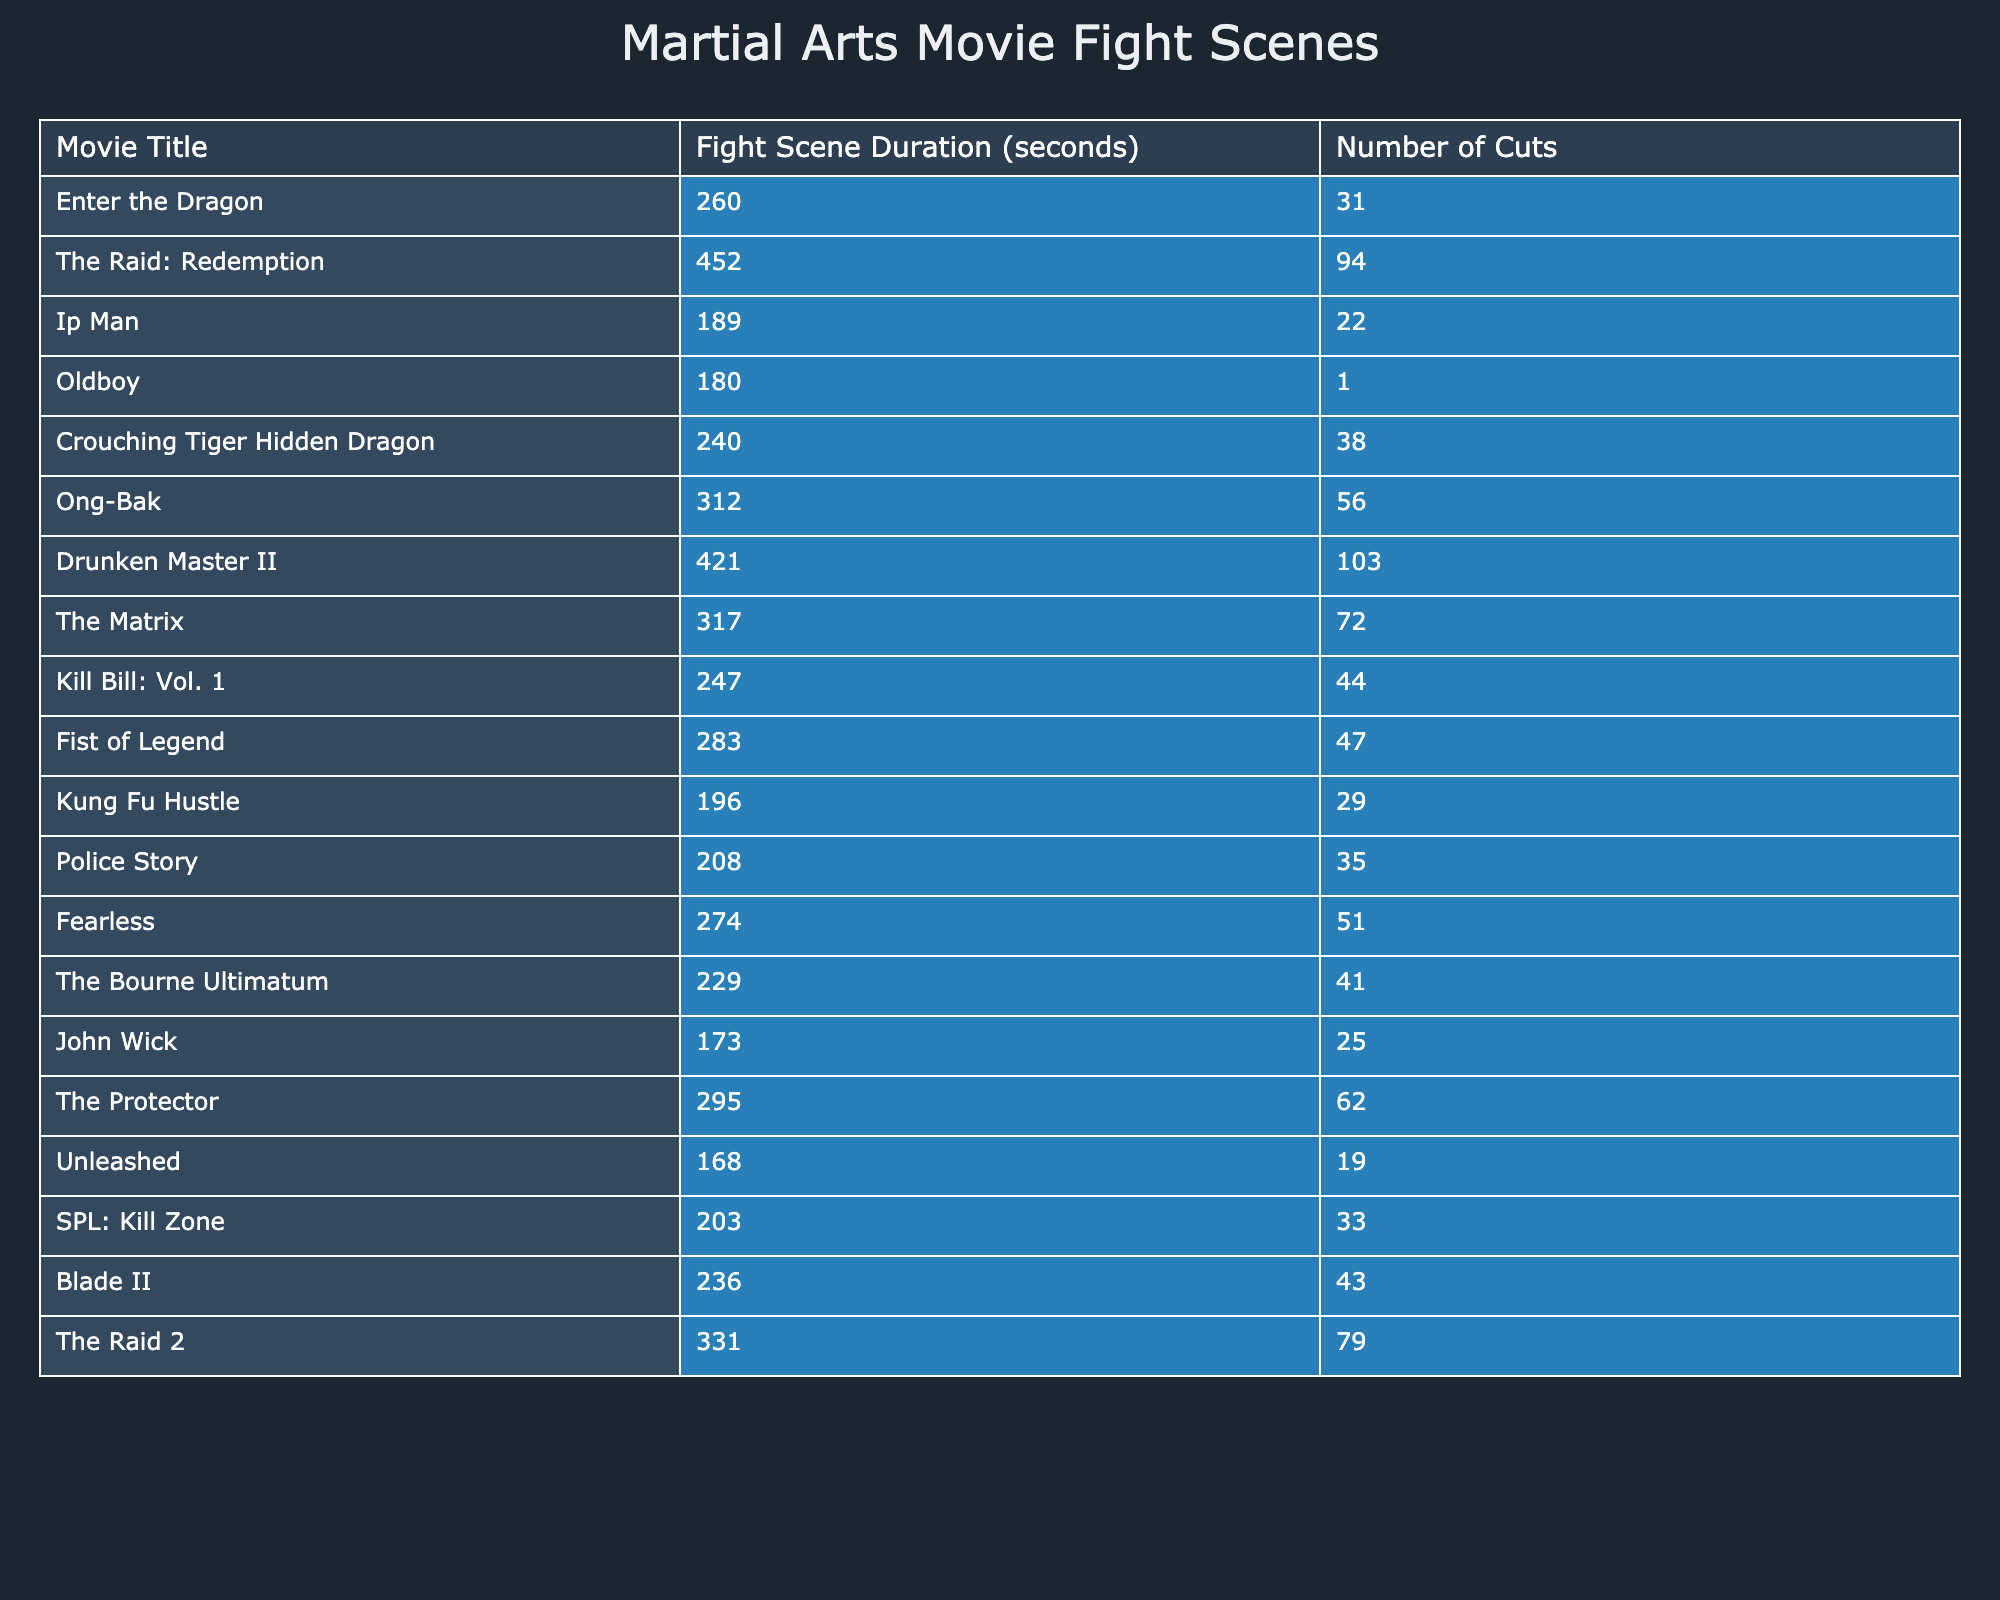What is the longest fight scene duration in the table? The longest fight scene duration in the table is found by scanning the "Fight Scene Duration" column. The highest value is 452 seconds, which corresponds to "The Raid: Redemption."
Answer: 452 seconds Which movie has the fewest cuts in its fight scene? By looking at the "Number of Cuts" column, the movie that has the fewest cuts is "Oldboy," with only 1 cut in its fight scene.
Answer: Oldboy What is the average duration of the fight scenes in the table? First, sum up all the values in the "Fight Scene Duration" column: 260 + 452 + 189 + 180 + 240 + 312 + 421 + 317 + 247 + 283 + 196 + 208 + 274 + 229 + 173 + 295 + 168 + 203 + 236 + 331 = 5040 seconds. Next, divide by the number of movies, which is 20: 5040 / 20 = 252 seconds.
Answer: 252 seconds How many movies have fight scenes longer than 300 seconds? By examining the "Fight Scene Duration" column, the following movies exceed 300 seconds: "The Raid: Redemption," "Drunken Master II," "Ong-Bak," "The Matrix," and "The Raid 2." This counts to a total of 5 movies.
Answer: 5 movies True or False: "Fist of Legend" has a longer fight scene duration than "Kill Bill: Vol. 1." In the "Fight Scene Duration" column, "Fist of Legend" has a duration of 283 seconds, while "Kill Bill: Vol. 1" has 247 seconds. Since 283 is greater than 247, the statement is true.
Answer: True What is the fight scene duration of "Fearless," and how does it compare to "The Protector"? "Fearless" has a fight scene duration of 274 seconds, while "The Protector" has 295 seconds. Comparing these values, "Fearless" is 21 seconds shorter than "The Protector."
Answer: 274 seconds, 21 seconds shorter Which movie has a fight scene duration that is closest to the average? The average is 252 seconds. Scanning the "Fight Scene Duration" column, "Police Story" with 208 seconds is 44 seconds shorter and "John Wick" with 173 seconds is 79 seconds shorter, but "Kung Fu Hustle" at 196 seconds is only 56 seconds shorter, making it the closest to the average duration.
Answer: Kung Fu Hustle What is the total number of cuts in the fight scenes of "Enter the Dragon" and "The Matrix"? Looking up both movies in the "Number of Cuts" column, "Enter the Dragon" has 31 cuts and "The Matrix" has 72 cuts. Adding these numbers together gives 31 + 72 = 103 cuts total.
Answer: 103 cuts Which movie has a higher number of cuts, "The Raid: Redemption" or "Drunken Master II"? In the "Number of Cuts" column, "The Raid: Redemption" has 94 cuts and "Drunken Master II" has 103 cuts. Since 103 is greater than 94, "Drunken Master II" has a higher number of cuts.
Answer: Drunken Master II 